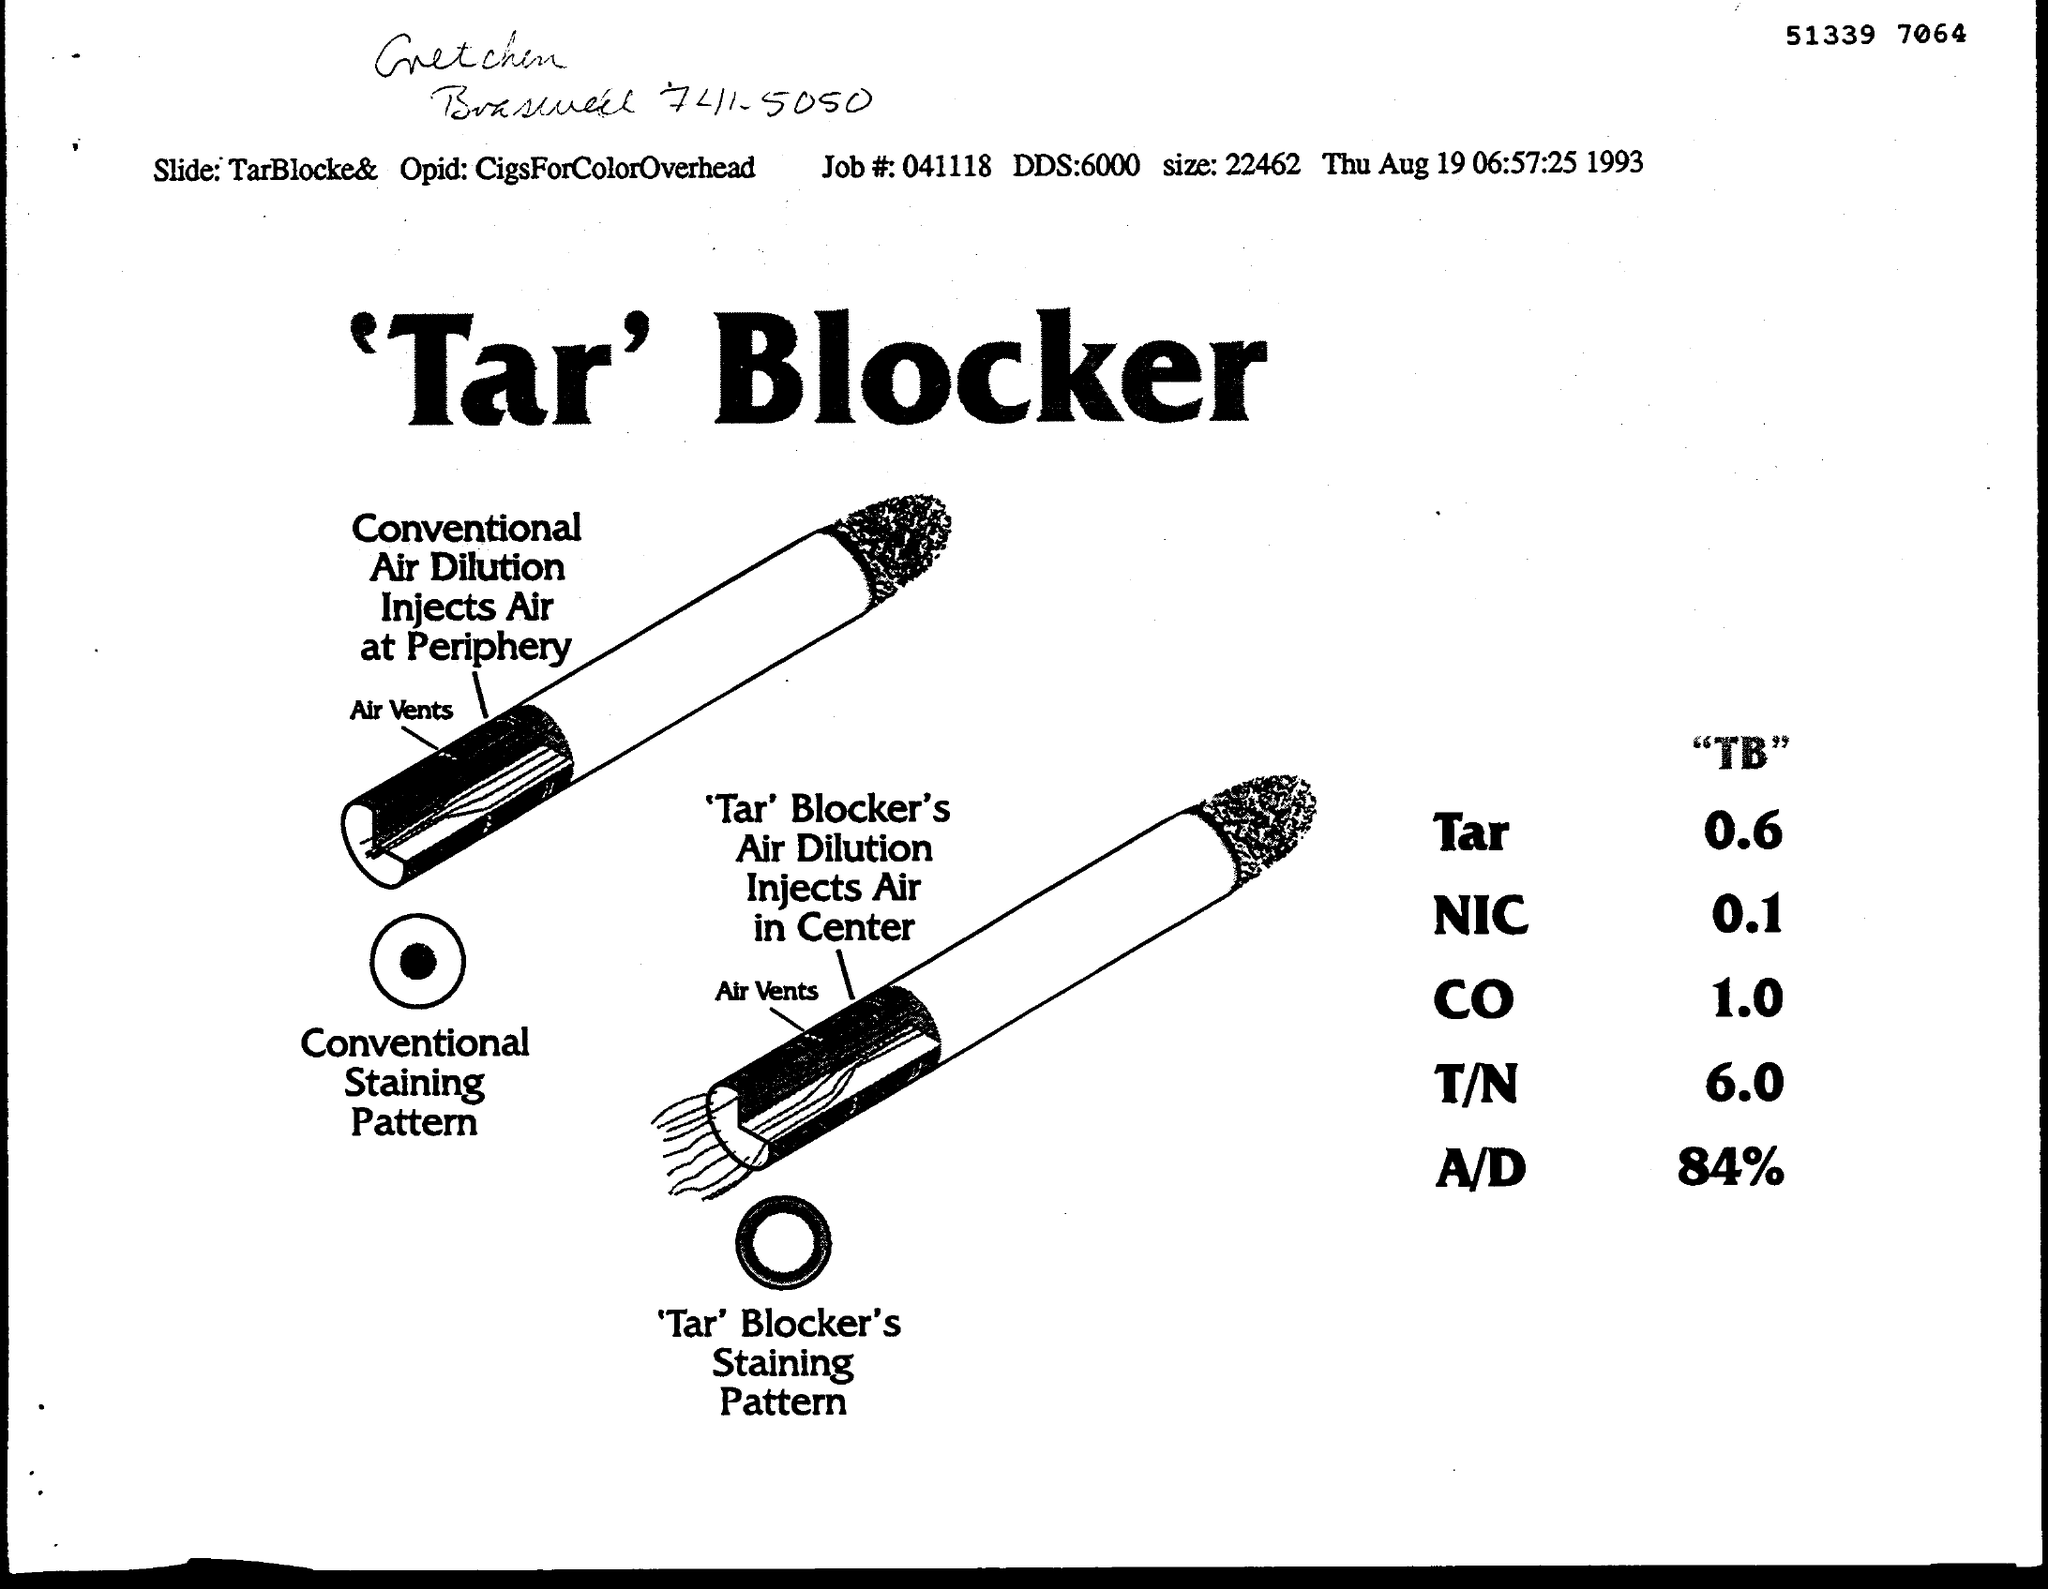What is the date on the document?
Make the answer very short. Thu Aug 19 06:57:25 1993. What is the Job #?
Give a very brief answer. 041118. What is the DDS?
Your answer should be very brief. 6000. What is the size?
Ensure brevity in your answer.  22462. What is the Slide?
Your response must be concise. TarBlocke&. What is the Opid?
Your answer should be compact. CigsForColorOverhead. 